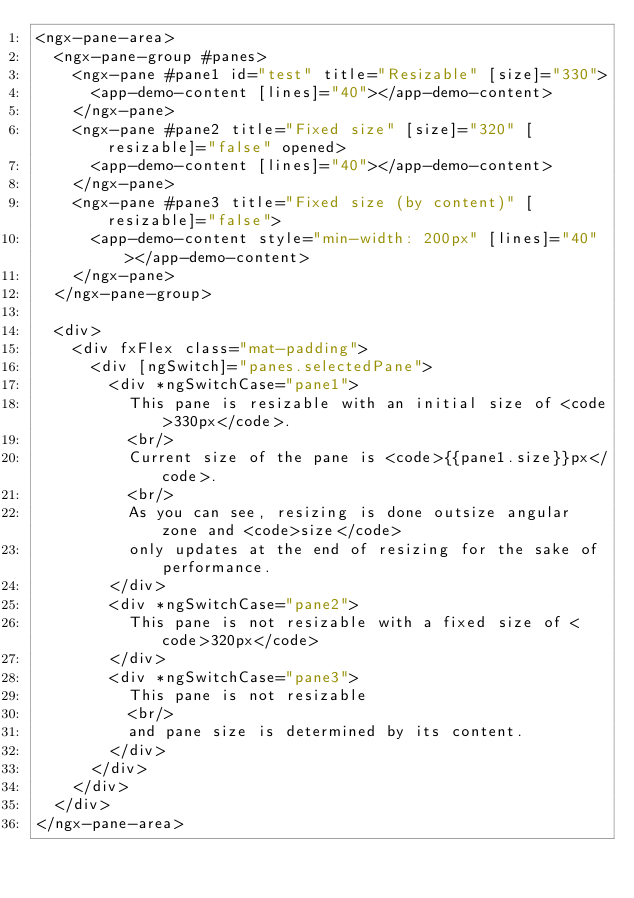Convert code to text. <code><loc_0><loc_0><loc_500><loc_500><_HTML_><ngx-pane-area>
  <ngx-pane-group #panes>
    <ngx-pane #pane1 id="test" title="Resizable" [size]="330">
      <app-demo-content [lines]="40"></app-demo-content>
    </ngx-pane>
    <ngx-pane #pane2 title="Fixed size" [size]="320" [resizable]="false" opened>
      <app-demo-content [lines]="40"></app-demo-content>
    </ngx-pane>
    <ngx-pane #pane3 title="Fixed size (by content)" [resizable]="false">
      <app-demo-content style="min-width: 200px" [lines]="40"></app-demo-content>
    </ngx-pane>
  </ngx-pane-group>

  <div>
    <div fxFlex class="mat-padding">
      <div [ngSwitch]="panes.selectedPane">
        <div *ngSwitchCase="pane1">
          This pane is resizable with an initial size of <code>330px</code>.
          <br/>
          Current size of the pane is <code>{{pane1.size}}px</code>.
          <br/>
          As you can see, resizing is done outsize angular zone and <code>size</code>
          only updates at the end of resizing for the sake of performance.
        </div>
        <div *ngSwitchCase="pane2">
          This pane is not resizable with a fixed size of <code>320px</code>
        </div>
        <div *ngSwitchCase="pane3">
          This pane is not resizable
          <br/>
          and pane size is determined by its content.
        </div>
      </div>
    </div>
  </div>
</ngx-pane-area>



</code> 